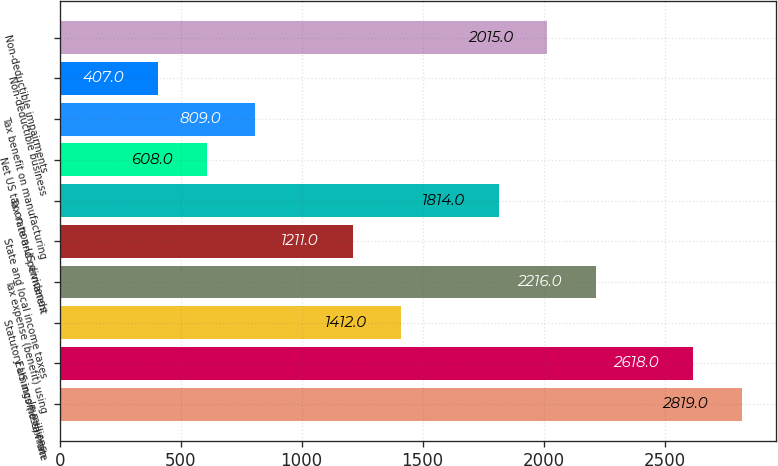<chart> <loc_0><loc_0><loc_500><loc_500><bar_chart><fcel>In millions<fcel>Earnings (loss) from<fcel>Statutory US income tax rate<fcel>Tax expense (benefit) using<fcel>State and local income taxes<fcel>Tax rate and permanent<fcel>Net US tax on non-US dividends<fcel>Tax benefit on manufacturing<fcel>Non-deductible business<fcel>Non-deductible impairments<nl><fcel>2819<fcel>2618<fcel>1412<fcel>2216<fcel>1211<fcel>1814<fcel>608<fcel>809<fcel>407<fcel>2015<nl></chart> 